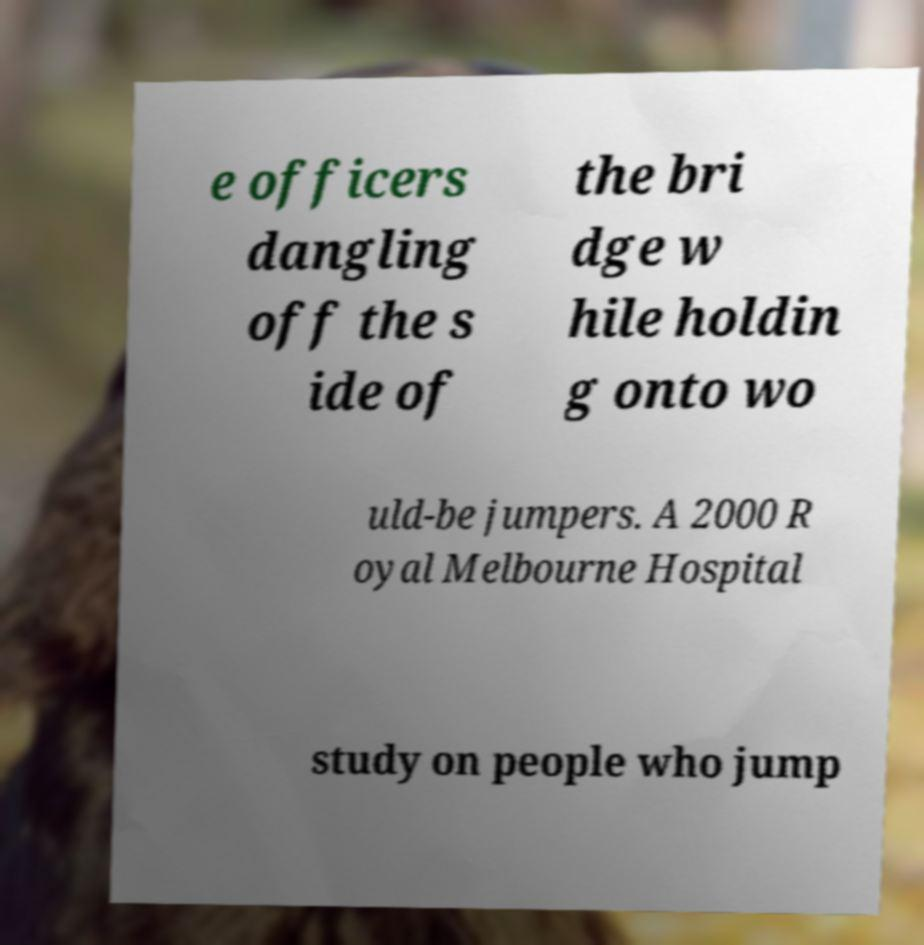Could you extract and type out the text from this image? e officers dangling off the s ide of the bri dge w hile holdin g onto wo uld-be jumpers. A 2000 R oyal Melbourne Hospital study on people who jump 